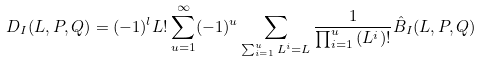Convert formula to latex. <formula><loc_0><loc_0><loc_500><loc_500>D _ { I } ( L , P , Q ) = ( - 1 ) ^ { l } L ! \sum _ { u = 1 } ^ { \infty } ( - 1 ) ^ { u } \sum _ { \sum _ { i = 1 } ^ { u } L ^ { i } = L } \frac { 1 } { \prod ^ { u } _ { i = 1 } { ( L ^ { i } ) ! } } \hat { B } _ { I } ( L , P , Q )</formula> 